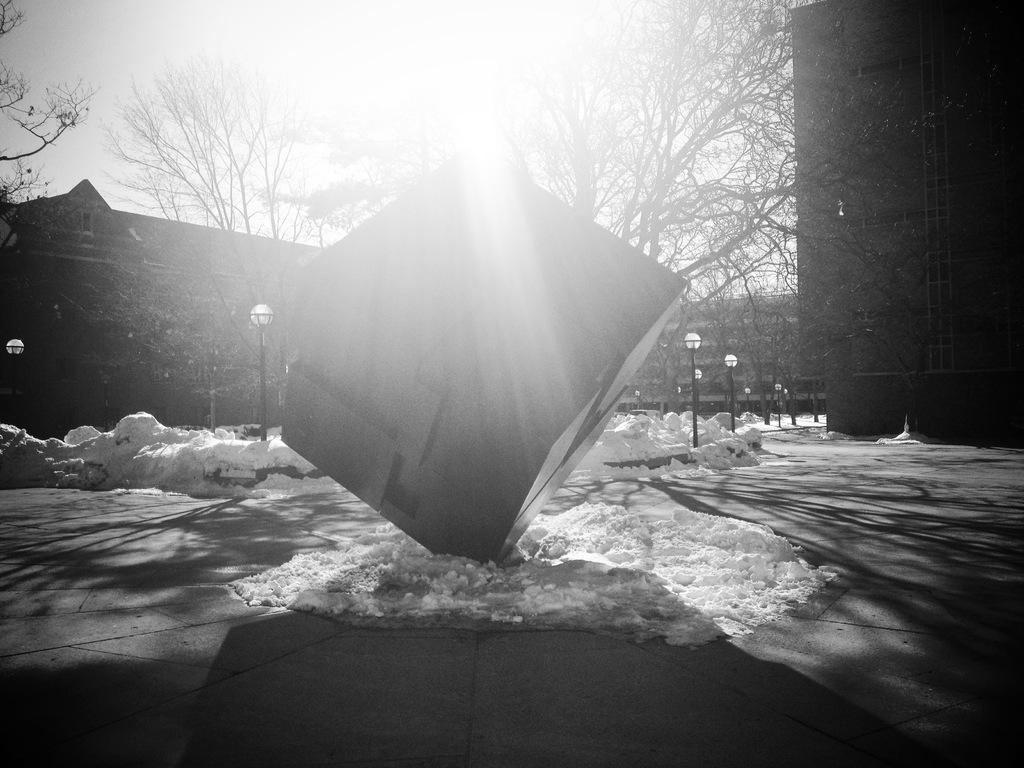Could you give a brief overview of what you see in this image? As we can see in the image there is snow, street lamps, buildings, trees and sky. 